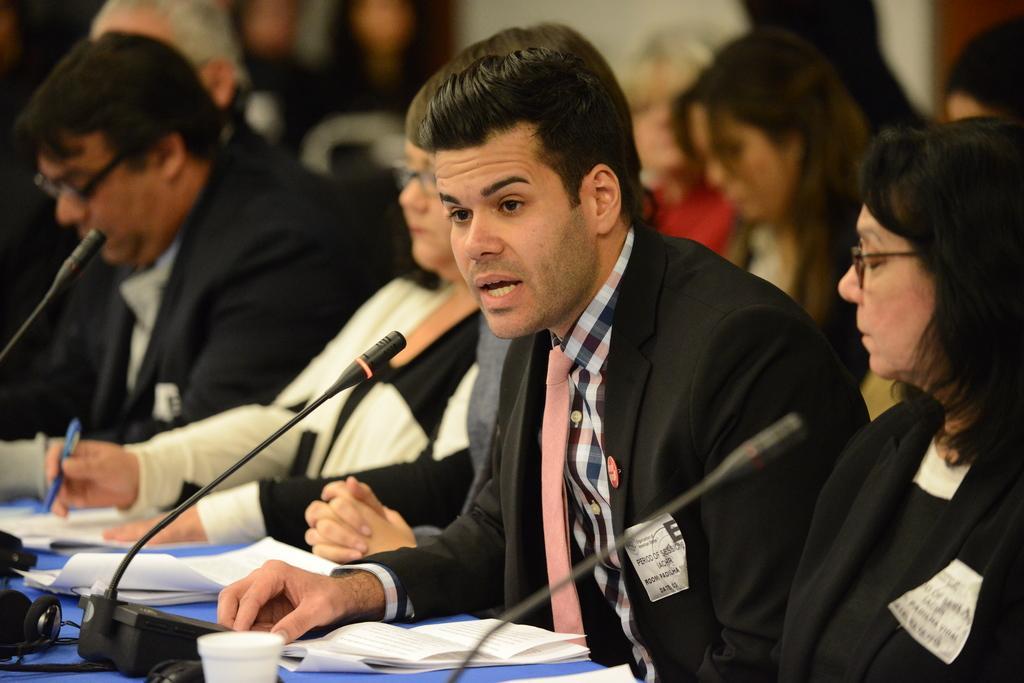How would you summarize this image in a sentence or two? In this image, we can see people and are wearing coats and some are wearing glasses and there is a lady holding a pen and we can see mics, papers and some other objects on the stand. 